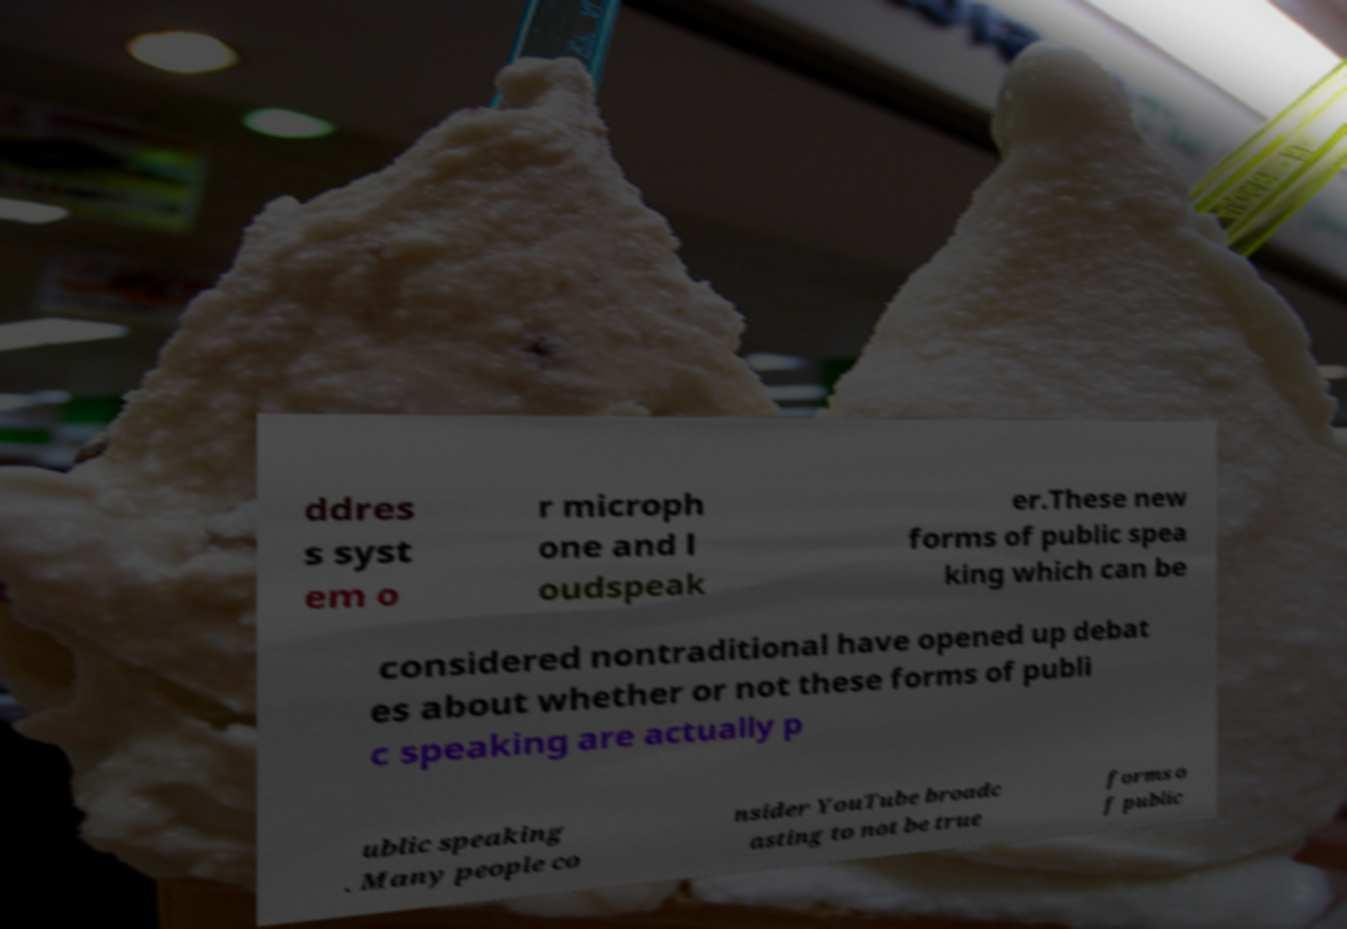Please read and relay the text visible in this image. What does it say? ddres s syst em o r microph one and l oudspeak er.These new forms of public spea king which can be considered nontraditional have opened up debat es about whether or not these forms of publi c speaking are actually p ublic speaking . Many people co nsider YouTube broadc asting to not be true forms o f public 